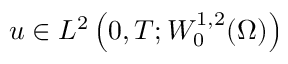<formula> <loc_0><loc_0><loc_500><loc_500>u \in L ^ { 2 } \left ( 0 , T ; W _ { 0 } ^ { 1 , 2 } ( \Omega ) \right )</formula> 